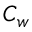<formula> <loc_0><loc_0><loc_500><loc_500>C _ { w }</formula> 